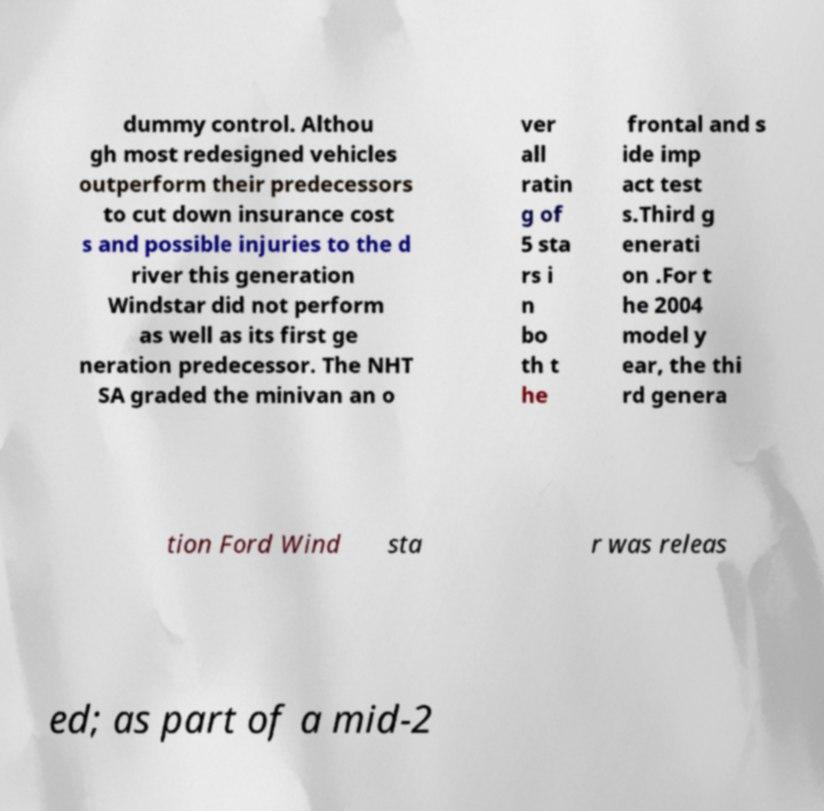Please identify and transcribe the text found in this image. dummy control. Althou gh most redesigned vehicles outperform their predecessors to cut down insurance cost s and possible injuries to the d river this generation Windstar did not perform as well as its first ge neration predecessor. The NHT SA graded the minivan an o ver all ratin g of 5 sta rs i n bo th t he frontal and s ide imp act test s.Third g enerati on .For t he 2004 model y ear, the thi rd genera tion Ford Wind sta r was releas ed; as part of a mid-2 